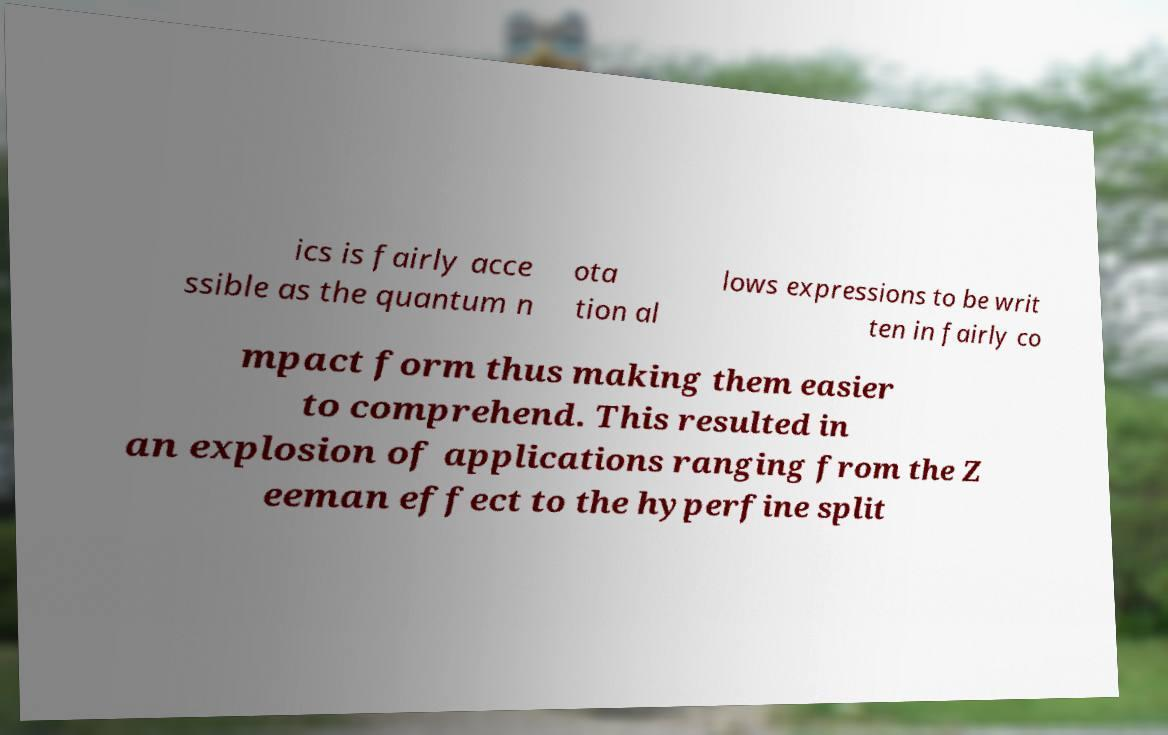Can you read and provide the text displayed in the image?This photo seems to have some interesting text. Can you extract and type it out for me? ics is fairly acce ssible as the quantum n ota tion al lows expressions to be writ ten in fairly co mpact form thus making them easier to comprehend. This resulted in an explosion of applications ranging from the Z eeman effect to the hyperfine split 